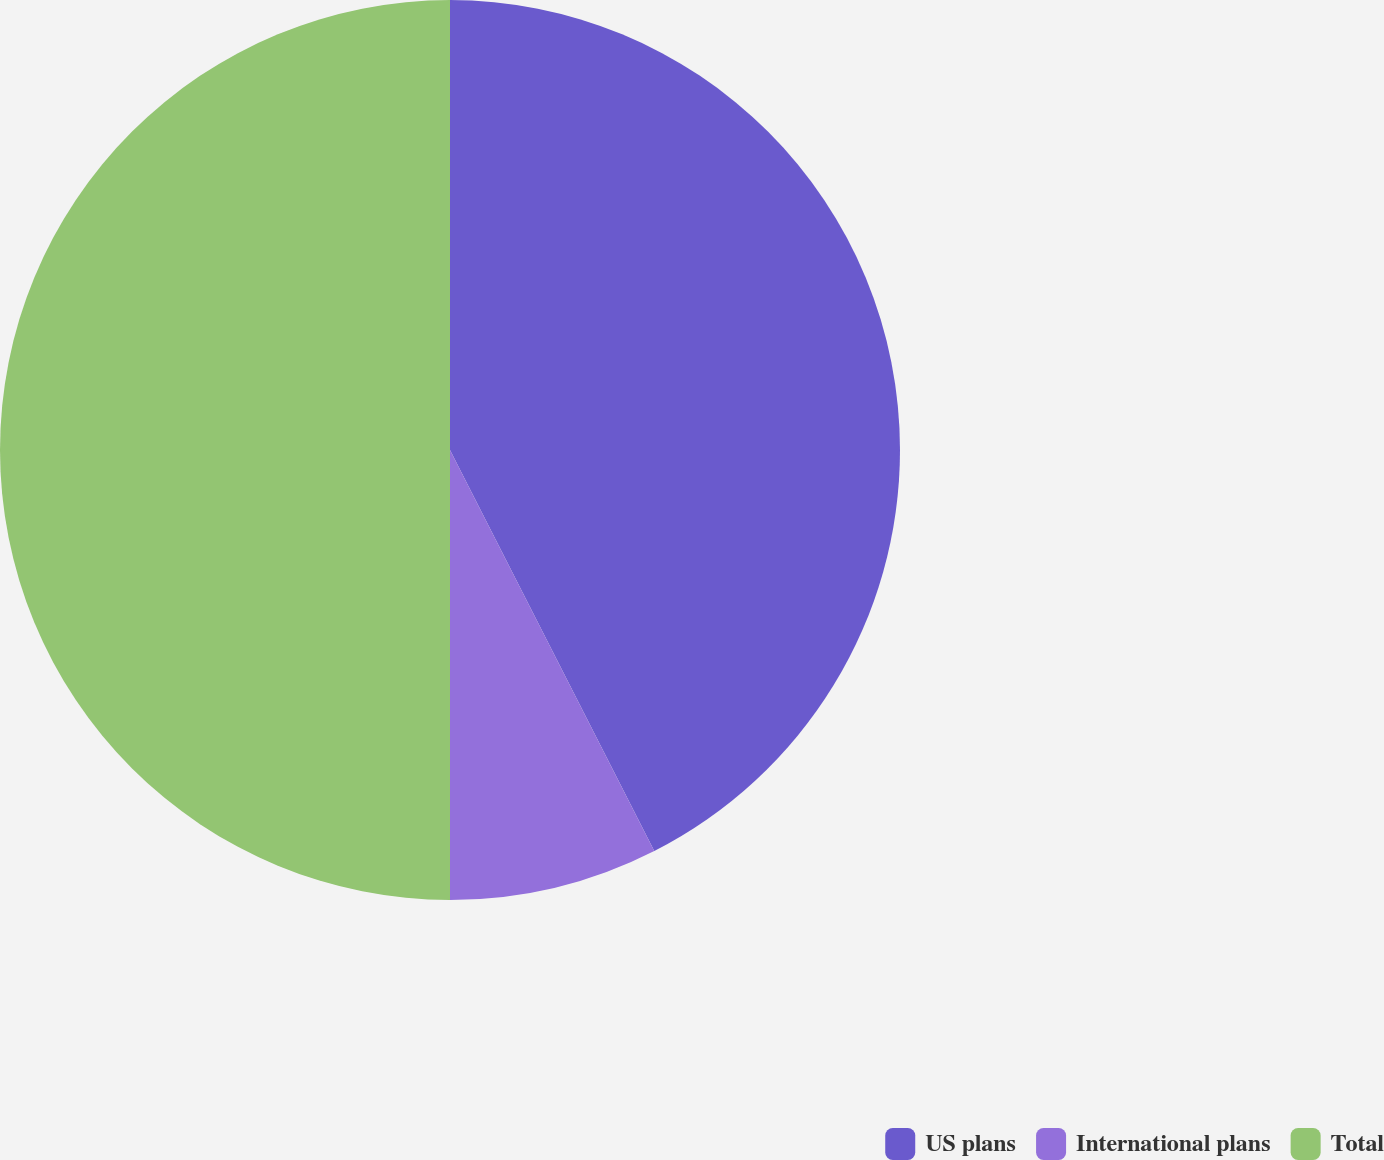Convert chart. <chart><loc_0><loc_0><loc_500><loc_500><pie_chart><fcel>US plans<fcel>International plans<fcel>Total<nl><fcel>42.5%<fcel>7.5%<fcel>50.0%<nl></chart> 